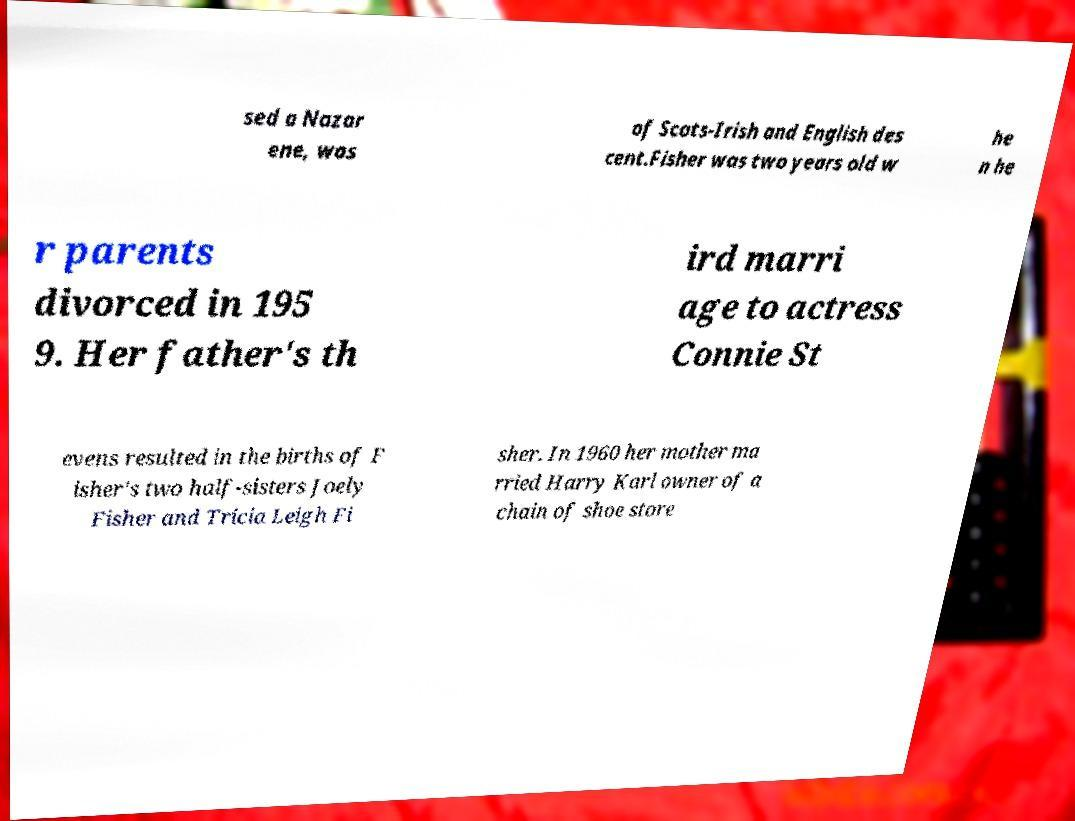Could you extract and type out the text from this image? sed a Nazar ene, was of Scots-Irish and English des cent.Fisher was two years old w he n he r parents divorced in 195 9. Her father's th ird marri age to actress Connie St evens resulted in the births of F isher's two half-sisters Joely Fisher and Tricia Leigh Fi sher. In 1960 her mother ma rried Harry Karl owner of a chain of shoe store 